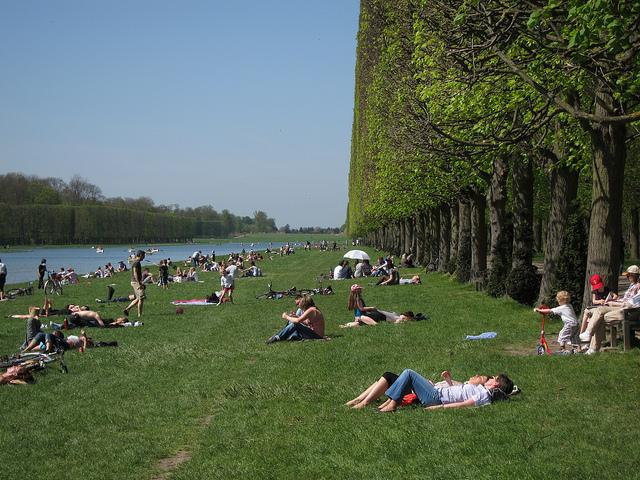Why are these people laying here?

Choices:
A) hungry
B) hiding
C) tired
D) good weather good weather 